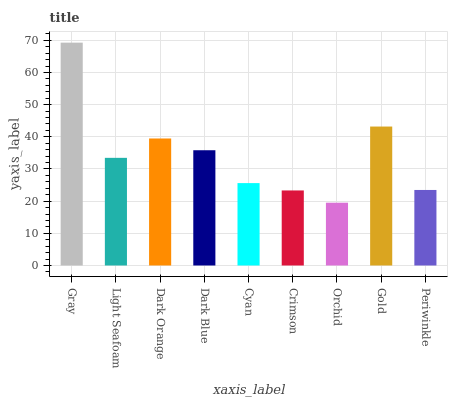Is Light Seafoam the minimum?
Answer yes or no. No. Is Light Seafoam the maximum?
Answer yes or no. No. Is Gray greater than Light Seafoam?
Answer yes or no. Yes. Is Light Seafoam less than Gray?
Answer yes or no. Yes. Is Light Seafoam greater than Gray?
Answer yes or no. No. Is Gray less than Light Seafoam?
Answer yes or no. No. Is Light Seafoam the high median?
Answer yes or no. Yes. Is Light Seafoam the low median?
Answer yes or no. Yes. Is Dark Blue the high median?
Answer yes or no. No. Is Gray the low median?
Answer yes or no. No. 